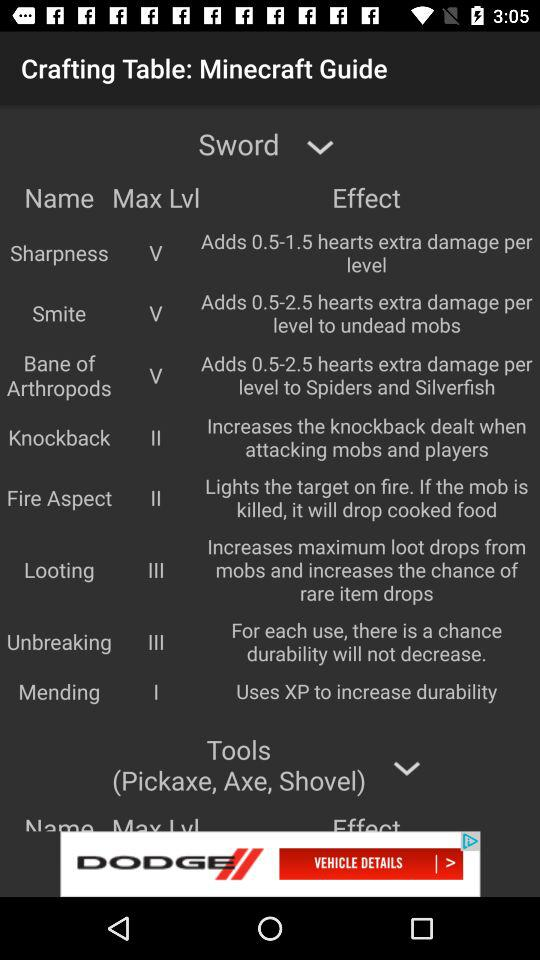What is the "Sharpness" maximum level? The sharpness maximum level is five. 